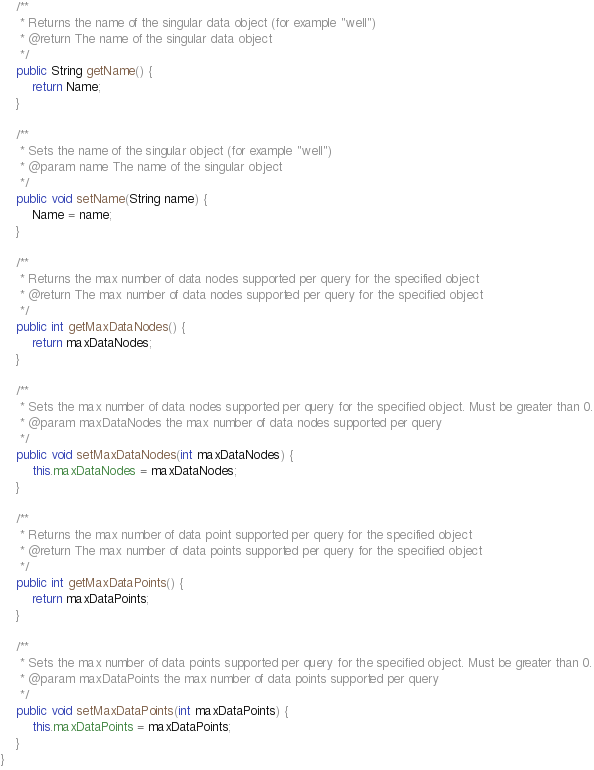<code> <loc_0><loc_0><loc_500><loc_500><_Java_>
    /**
     * Returns the name of the singular data object (for example "well")
     * @return The name of the singular data object
     */
    public String getName() {
        return Name;
    }

    /**
     * Sets the name of the singular object (for example "well")
     * @param name The name of the singular object
     */
    public void setName(String name) {
        Name = name;
    }

    /**
     * Returns the max number of data nodes supported per query for the specified object
     * @return The max number of data nodes supported per query for the specified object
     */
    public int getMaxDataNodes() {
        return maxDataNodes;
    }

    /**
     * Sets the max number of data nodes supported per query for the specified object. Must be greater than 0.
     * @param maxDataNodes the max number of data nodes supported per query
     */
    public void setMaxDataNodes(int maxDataNodes) {
        this.maxDataNodes = maxDataNodes;
    }

    /**
     * Returns the max number of data point supported per query for the specified object
     * @return The max number of data points supported per query for the specified object
     */
    public int getMaxDataPoints() {
        return maxDataPoints;
    }

    /**
     * Sets the max number of data points supported per query for the specified object. Must be greater than 0.
     * @param maxDataPoints the max number of data points supported per query
     */
    public void setMaxDataPoints(int maxDataPoints) {
        this.maxDataPoints = maxDataPoints;
    }
}
</code> 